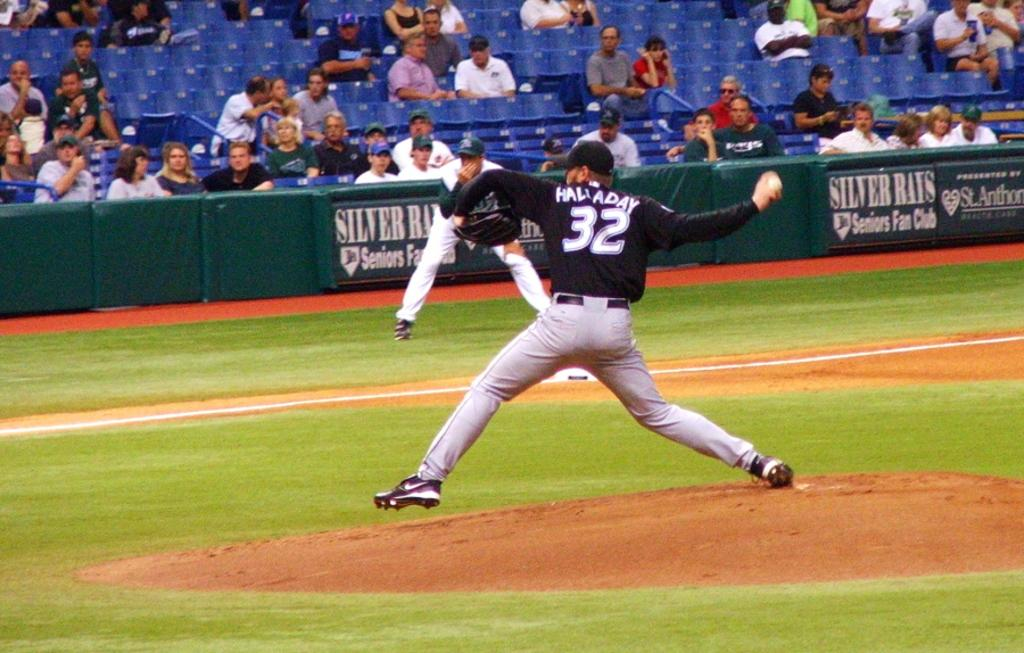<image>
Relay a brief, clear account of the picture shown. A baseball player with the number 32 on his back 